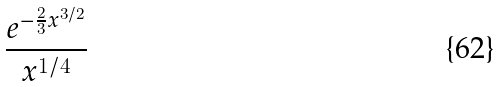<formula> <loc_0><loc_0><loc_500><loc_500>\frac { e ^ { - \frac { 2 } { 3 } x ^ { 3 / 2 } } } { x ^ { 1 / 4 } }</formula> 